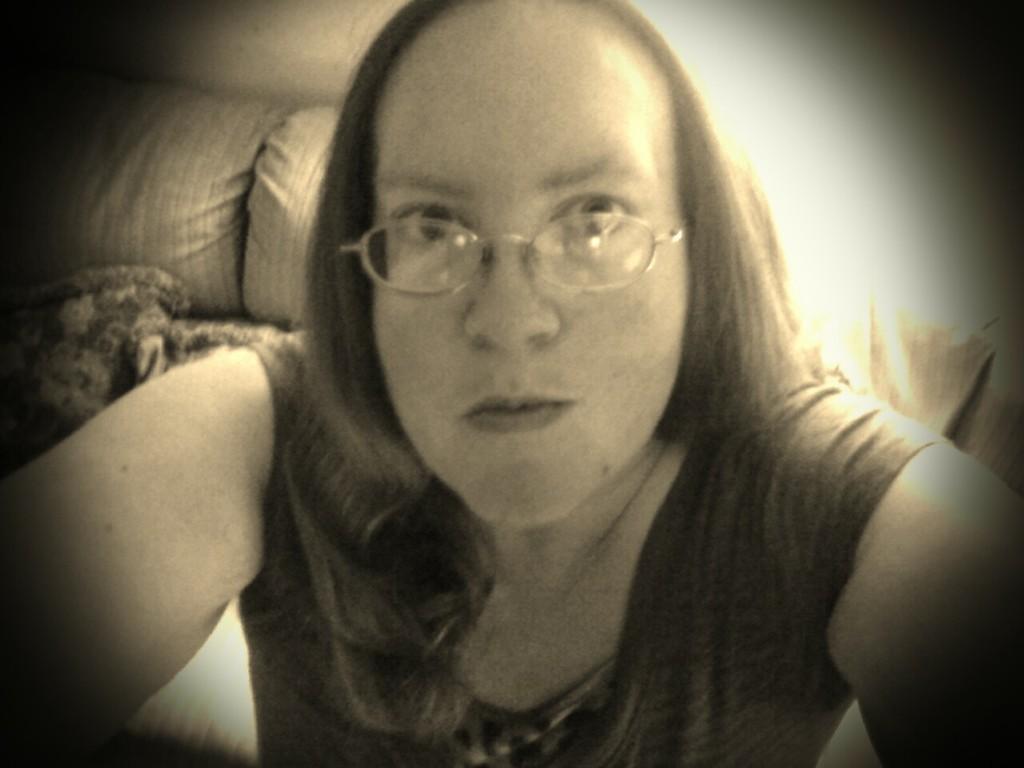Please provide a concise description of this image. In this image person is taking the picture. At the background there is a sofa. 